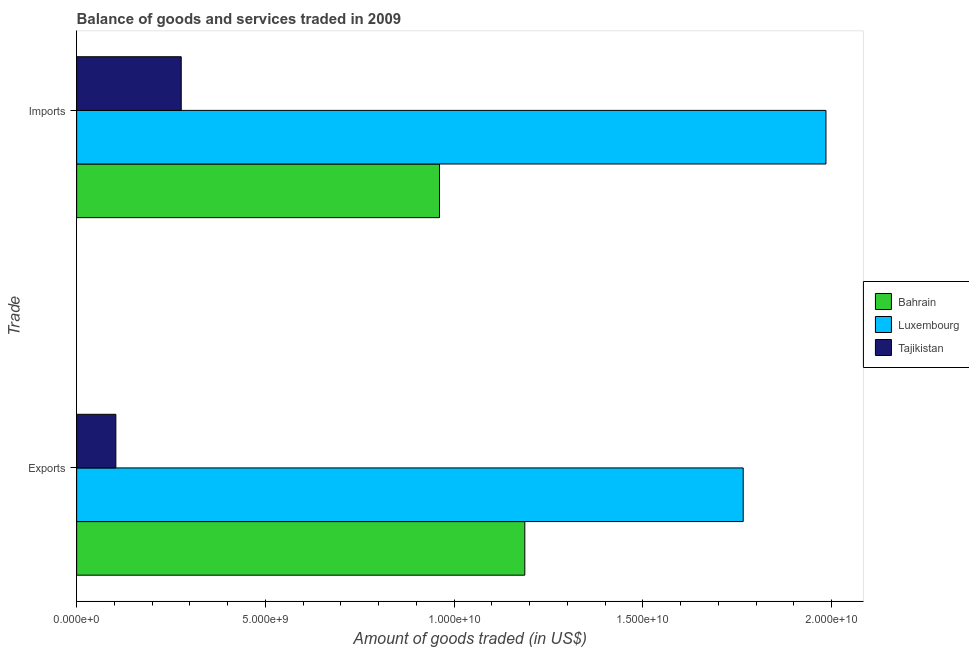How many different coloured bars are there?
Keep it short and to the point. 3. How many bars are there on the 1st tick from the bottom?
Your answer should be compact. 3. What is the label of the 2nd group of bars from the top?
Keep it short and to the point. Exports. What is the amount of goods exported in Tajikistan?
Provide a succinct answer. 1.04e+09. Across all countries, what is the maximum amount of goods exported?
Your response must be concise. 1.77e+1. Across all countries, what is the minimum amount of goods exported?
Give a very brief answer. 1.04e+09. In which country was the amount of goods exported maximum?
Offer a very short reply. Luxembourg. In which country was the amount of goods imported minimum?
Your response must be concise. Tajikistan. What is the total amount of goods imported in the graph?
Make the answer very short. 3.22e+1. What is the difference between the amount of goods exported in Tajikistan and that in Bahrain?
Offer a terse response. -1.08e+1. What is the difference between the amount of goods imported in Bahrain and the amount of goods exported in Luxembourg?
Your response must be concise. -8.05e+09. What is the average amount of goods exported per country?
Ensure brevity in your answer.  1.02e+1. What is the difference between the amount of goods exported and amount of goods imported in Bahrain?
Offer a terse response. 2.26e+09. What is the ratio of the amount of goods exported in Luxembourg to that in Bahrain?
Ensure brevity in your answer.  1.49. Is the amount of goods imported in Bahrain less than that in Luxembourg?
Your answer should be compact. Yes. What does the 1st bar from the top in Exports represents?
Ensure brevity in your answer.  Tajikistan. What does the 1st bar from the bottom in Imports represents?
Provide a succinct answer. Bahrain. How many countries are there in the graph?
Offer a very short reply. 3. What is the difference between two consecutive major ticks on the X-axis?
Provide a succinct answer. 5.00e+09. Does the graph contain any zero values?
Provide a succinct answer. No. Does the graph contain grids?
Make the answer very short. No. Where does the legend appear in the graph?
Keep it short and to the point. Center right. How are the legend labels stacked?
Ensure brevity in your answer.  Vertical. What is the title of the graph?
Provide a succinct answer. Balance of goods and services traded in 2009. Does "Equatorial Guinea" appear as one of the legend labels in the graph?
Your answer should be very brief. No. What is the label or title of the X-axis?
Offer a very short reply. Amount of goods traded (in US$). What is the label or title of the Y-axis?
Offer a terse response. Trade. What is the Amount of goods traded (in US$) of Bahrain in Exports?
Provide a succinct answer. 1.19e+1. What is the Amount of goods traded (in US$) of Luxembourg in Exports?
Ensure brevity in your answer.  1.77e+1. What is the Amount of goods traded (in US$) of Tajikistan in Exports?
Provide a succinct answer. 1.04e+09. What is the Amount of goods traded (in US$) in Bahrain in Imports?
Keep it short and to the point. 9.61e+09. What is the Amount of goods traded (in US$) in Luxembourg in Imports?
Ensure brevity in your answer.  1.99e+1. What is the Amount of goods traded (in US$) in Tajikistan in Imports?
Give a very brief answer. 2.77e+09. Across all Trade, what is the maximum Amount of goods traded (in US$) of Bahrain?
Your answer should be very brief. 1.19e+1. Across all Trade, what is the maximum Amount of goods traded (in US$) of Luxembourg?
Give a very brief answer. 1.99e+1. Across all Trade, what is the maximum Amount of goods traded (in US$) of Tajikistan?
Ensure brevity in your answer.  2.77e+09. Across all Trade, what is the minimum Amount of goods traded (in US$) of Bahrain?
Provide a short and direct response. 9.61e+09. Across all Trade, what is the minimum Amount of goods traded (in US$) in Luxembourg?
Your answer should be compact. 1.77e+1. Across all Trade, what is the minimum Amount of goods traded (in US$) of Tajikistan?
Offer a very short reply. 1.04e+09. What is the total Amount of goods traded (in US$) of Bahrain in the graph?
Your answer should be compact. 2.15e+1. What is the total Amount of goods traded (in US$) of Luxembourg in the graph?
Your answer should be very brief. 3.75e+1. What is the total Amount of goods traded (in US$) in Tajikistan in the graph?
Your answer should be compact. 3.81e+09. What is the difference between the Amount of goods traded (in US$) of Bahrain in Exports and that in Imports?
Offer a terse response. 2.26e+09. What is the difference between the Amount of goods traded (in US$) in Luxembourg in Exports and that in Imports?
Provide a succinct answer. -2.19e+09. What is the difference between the Amount of goods traded (in US$) of Tajikistan in Exports and that in Imports?
Your answer should be compact. -1.73e+09. What is the difference between the Amount of goods traded (in US$) in Bahrain in Exports and the Amount of goods traded (in US$) in Luxembourg in Imports?
Offer a very short reply. -7.98e+09. What is the difference between the Amount of goods traded (in US$) of Bahrain in Exports and the Amount of goods traded (in US$) of Tajikistan in Imports?
Your answer should be very brief. 9.10e+09. What is the difference between the Amount of goods traded (in US$) of Luxembourg in Exports and the Amount of goods traded (in US$) of Tajikistan in Imports?
Your answer should be very brief. 1.49e+1. What is the average Amount of goods traded (in US$) in Bahrain per Trade?
Make the answer very short. 1.07e+1. What is the average Amount of goods traded (in US$) of Luxembourg per Trade?
Provide a succinct answer. 1.88e+1. What is the average Amount of goods traded (in US$) in Tajikistan per Trade?
Keep it short and to the point. 1.90e+09. What is the difference between the Amount of goods traded (in US$) of Bahrain and Amount of goods traded (in US$) of Luxembourg in Exports?
Offer a terse response. -5.79e+09. What is the difference between the Amount of goods traded (in US$) of Bahrain and Amount of goods traded (in US$) of Tajikistan in Exports?
Give a very brief answer. 1.08e+1. What is the difference between the Amount of goods traded (in US$) of Luxembourg and Amount of goods traded (in US$) of Tajikistan in Exports?
Ensure brevity in your answer.  1.66e+1. What is the difference between the Amount of goods traded (in US$) of Bahrain and Amount of goods traded (in US$) of Luxembourg in Imports?
Provide a short and direct response. -1.02e+1. What is the difference between the Amount of goods traded (in US$) in Bahrain and Amount of goods traded (in US$) in Tajikistan in Imports?
Offer a very short reply. 6.84e+09. What is the difference between the Amount of goods traded (in US$) in Luxembourg and Amount of goods traded (in US$) in Tajikistan in Imports?
Provide a short and direct response. 1.71e+1. What is the ratio of the Amount of goods traded (in US$) in Bahrain in Exports to that in Imports?
Ensure brevity in your answer.  1.24. What is the ratio of the Amount of goods traded (in US$) of Luxembourg in Exports to that in Imports?
Offer a terse response. 0.89. What is the ratio of the Amount of goods traded (in US$) of Tajikistan in Exports to that in Imports?
Your answer should be compact. 0.37. What is the difference between the highest and the second highest Amount of goods traded (in US$) in Bahrain?
Offer a terse response. 2.26e+09. What is the difference between the highest and the second highest Amount of goods traded (in US$) of Luxembourg?
Make the answer very short. 2.19e+09. What is the difference between the highest and the second highest Amount of goods traded (in US$) of Tajikistan?
Offer a very short reply. 1.73e+09. What is the difference between the highest and the lowest Amount of goods traded (in US$) in Bahrain?
Give a very brief answer. 2.26e+09. What is the difference between the highest and the lowest Amount of goods traded (in US$) in Luxembourg?
Your response must be concise. 2.19e+09. What is the difference between the highest and the lowest Amount of goods traded (in US$) in Tajikistan?
Keep it short and to the point. 1.73e+09. 